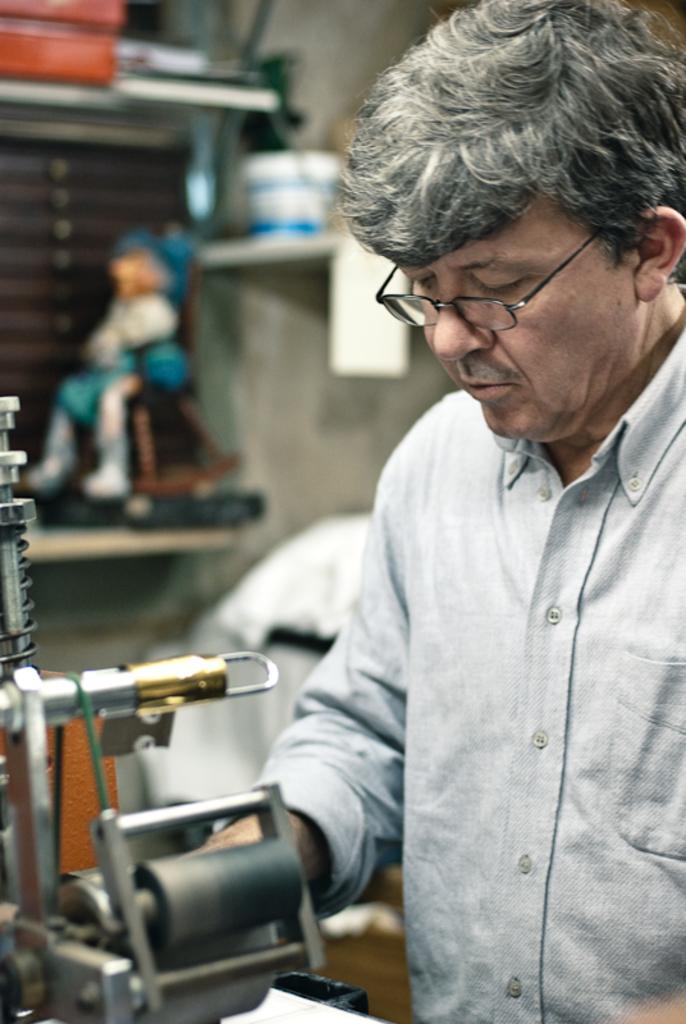In one or two sentences, can you explain what this image depicts? The man on the right side who is wearing the grey shirt is standing. He is wearing the spectacles. In front of him, we see the machinery equipment. In the background, we see a toy is placed in the shelf. Beside that, we see a wall and a white color cloth. At the top, we see white bucket and a red color thing. This picture is blurred in the background. 